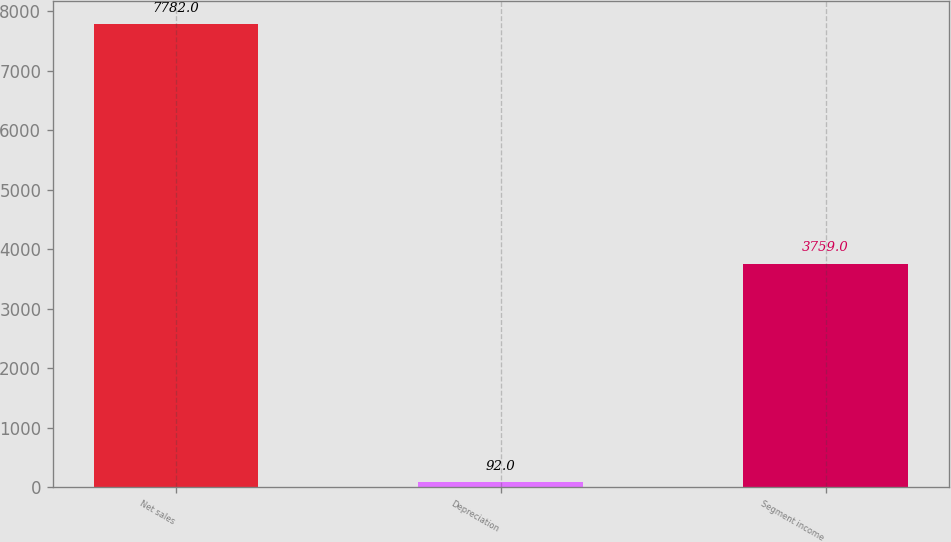Convert chart to OTSL. <chart><loc_0><loc_0><loc_500><loc_500><bar_chart><fcel>Net sales<fcel>Depreciation<fcel>Segment income<nl><fcel>7782<fcel>92<fcel>3759<nl></chart> 